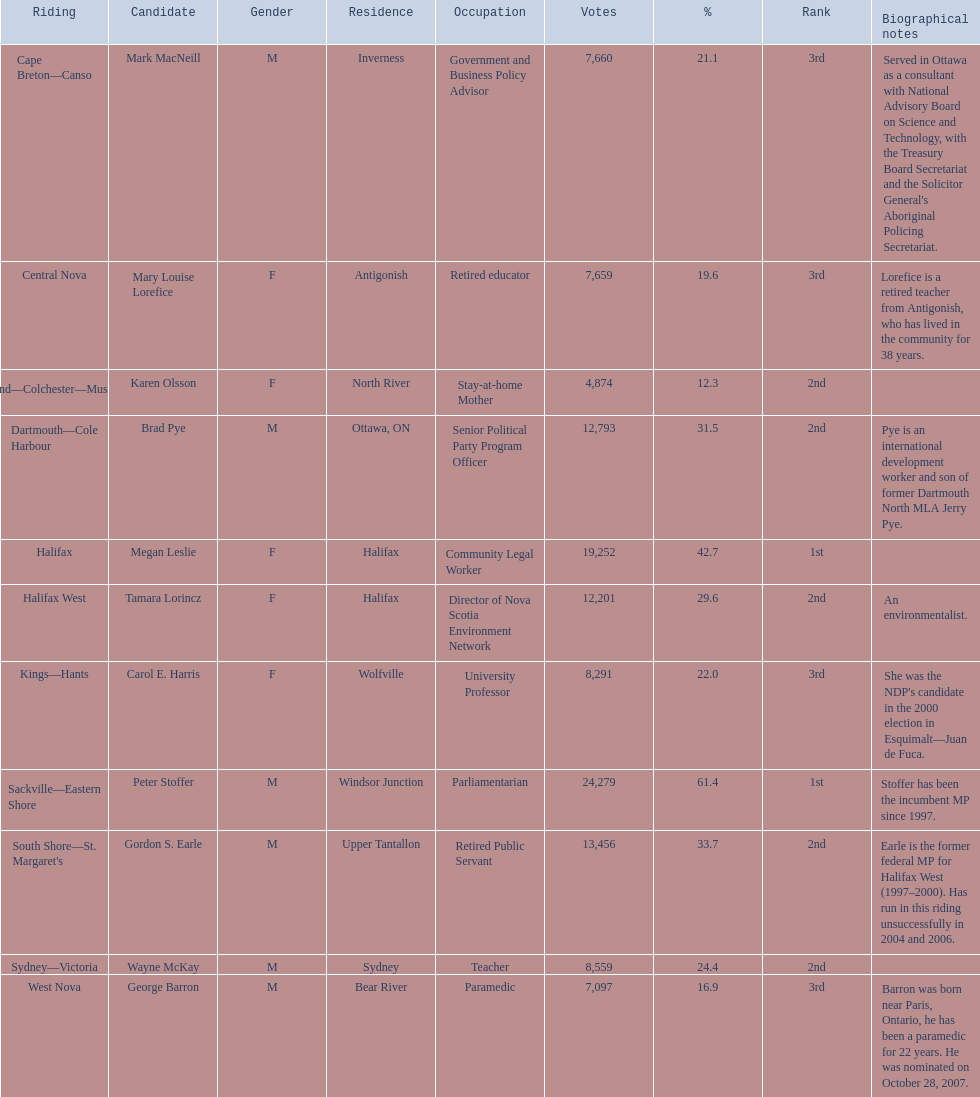Can you list all the new democratic party candidates in the 2008 canadian federal election? Mark MacNeill, Mary Louise Lorefice, Karen Olsson, Brad Pye, Megan Leslie, Tamara Lorincz, Carol E. Harris, Peter Stoffer, Gordon S. Earle, Wayne McKay, George Barron. Additionally, which candidate had more votes, mark macneill or karen olsson? Mark MacNeill. 